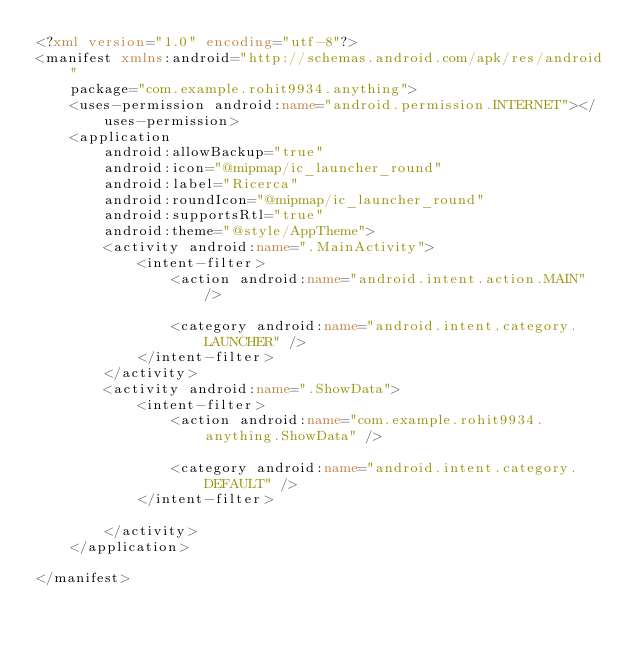Convert code to text. <code><loc_0><loc_0><loc_500><loc_500><_XML_><?xml version="1.0" encoding="utf-8"?>
<manifest xmlns:android="http://schemas.android.com/apk/res/android"
    package="com.example.rohit9934.anything">
    <uses-permission android:name="android.permission.INTERNET"></uses-permission>
    <application
        android:allowBackup="true"
        android:icon="@mipmap/ic_launcher_round"
        android:label="Ricerca"
        android:roundIcon="@mipmap/ic_launcher_round"
        android:supportsRtl="true"
        android:theme="@style/AppTheme">
        <activity android:name=".MainActivity">
            <intent-filter>
                <action android:name="android.intent.action.MAIN" />

                <category android:name="android.intent.category.LAUNCHER" />
            </intent-filter>
        </activity>
        <activity android:name=".ShowData">
            <intent-filter>
                <action android:name="com.example.rohit9934.anything.ShowData" />

                <category android:name="android.intent.category.DEFAULT" />
            </intent-filter>

        </activity>
    </application>

</manifest></code> 